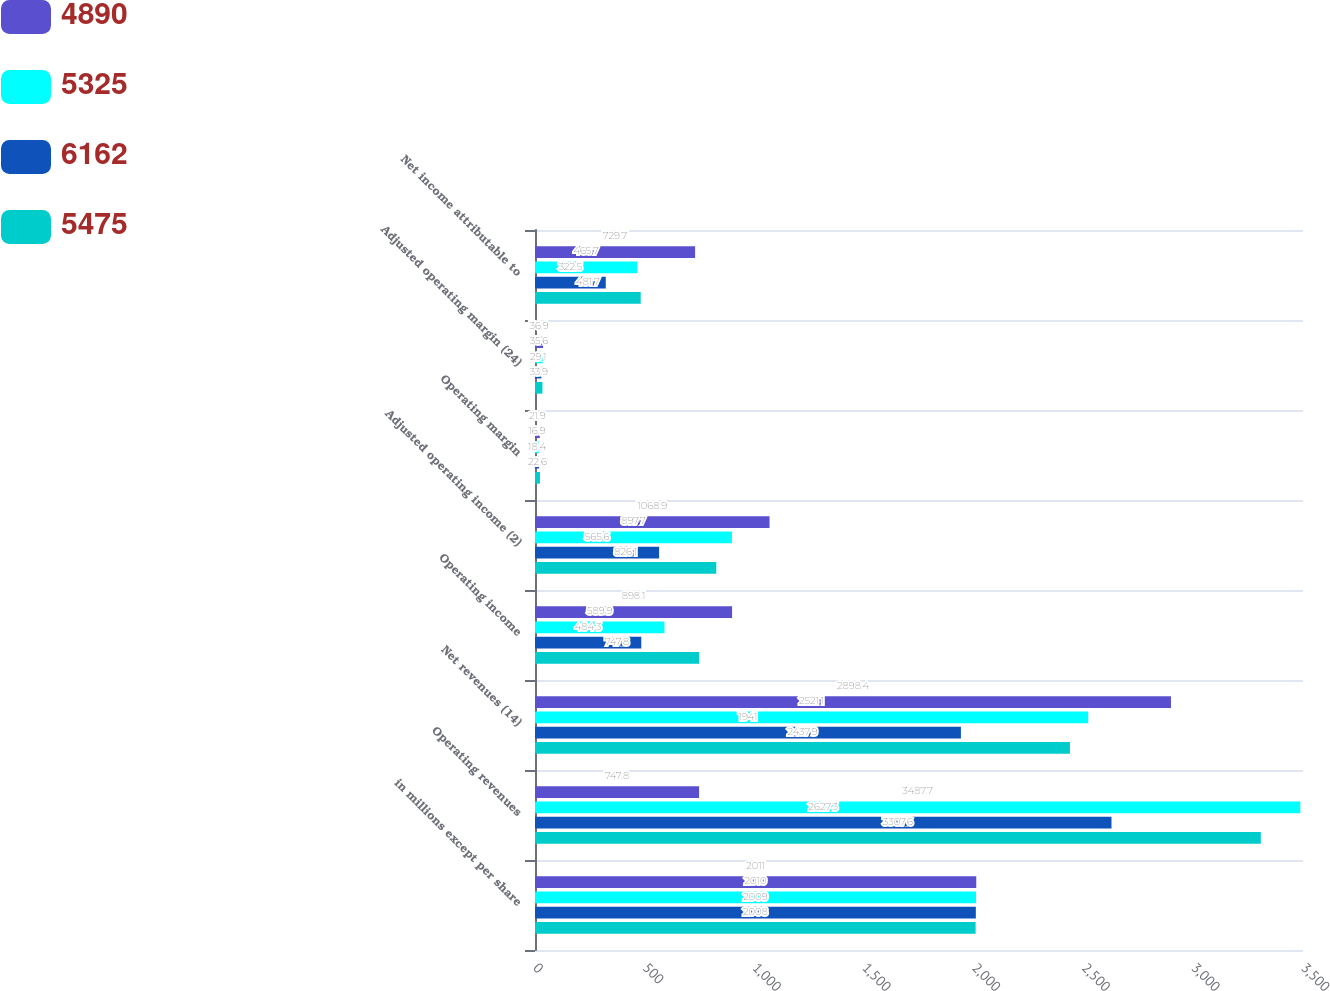<chart> <loc_0><loc_0><loc_500><loc_500><stacked_bar_chart><ecel><fcel>in millions except per share<fcel>Operating revenues<fcel>Net revenues (14)<fcel>Operating income<fcel>Adjusted operating income (2)<fcel>Operating margin<fcel>Adjusted operating margin (24)<fcel>Net income attributable to<nl><fcel>4890<fcel>2011<fcel>747.8<fcel>2898.4<fcel>898.1<fcel>1068.9<fcel>21.9<fcel>36.9<fcel>729.7<nl><fcel>5325<fcel>2010<fcel>3487.7<fcel>2521.1<fcel>589.9<fcel>897.7<fcel>16.9<fcel>35.6<fcel>465.7<nl><fcel>6162<fcel>2009<fcel>2627.3<fcel>1941<fcel>484.3<fcel>565.6<fcel>18.4<fcel>29.1<fcel>322.5<nl><fcel>5475<fcel>2008<fcel>3307.6<fcel>2437.9<fcel>747.8<fcel>826.1<fcel>22.6<fcel>33.9<fcel>481.7<nl></chart> 